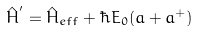<formula> <loc_0><loc_0><loc_500><loc_500>\hat { H } ^ { ^ { \prime } } = \hat { H } _ { e f f } + \hbar { E } _ { 0 } ( a + a ^ { + } )</formula> 